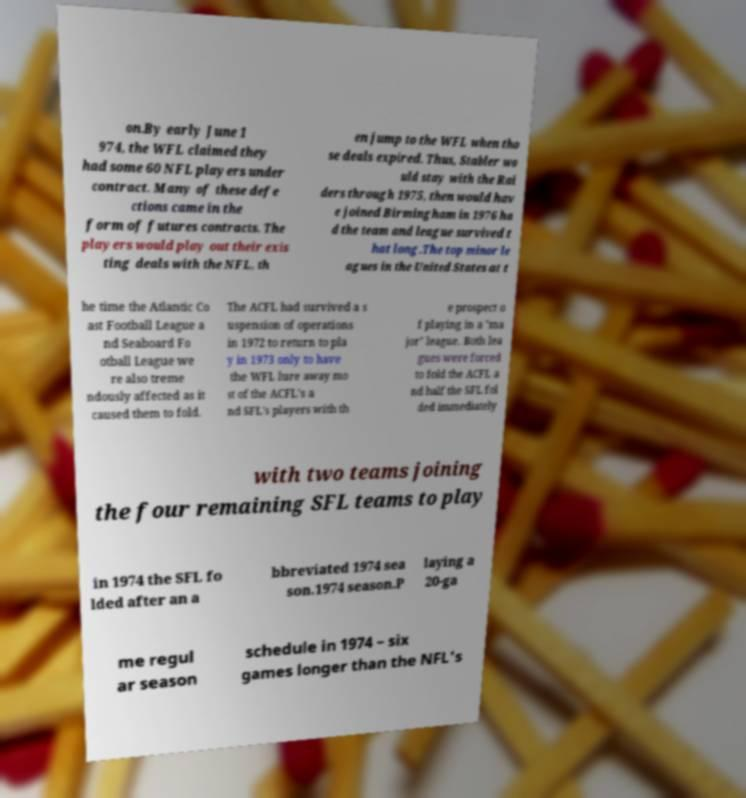I need the written content from this picture converted into text. Can you do that? on.By early June 1 974, the WFL claimed they had some 60 NFL players under contract. Many of these defe ctions came in the form of futures contracts. The players would play out their exis ting deals with the NFL, th en jump to the WFL when tho se deals expired. Thus, Stabler wo uld stay with the Rai ders through 1975, then would hav e joined Birmingham in 1976 ha d the team and league survived t hat long.The top minor le agues in the United States at t he time the Atlantic Co ast Football League a nd Seaboard Fo otball League we re also treme ndously affected as it caused them to fold. The ACFL had survived a s uspension of operations in 1972 to return to pla y in 1973 only to have the WFL lure away mo st of the ACFL's a nd SFL's players with th e prospect o f playing in a "ma jor" league. Both lea gues were forced to fold the ACFL a nd half the SFL fol ded immediately with two teams joining the four remaining SFL teams to play in 1974 the SFL fo lded after an a bbreviated 1974 sea son.1974 season.P laying a 20-ga me regul ar season schedule in 1974 – six games longer than the NFL's 